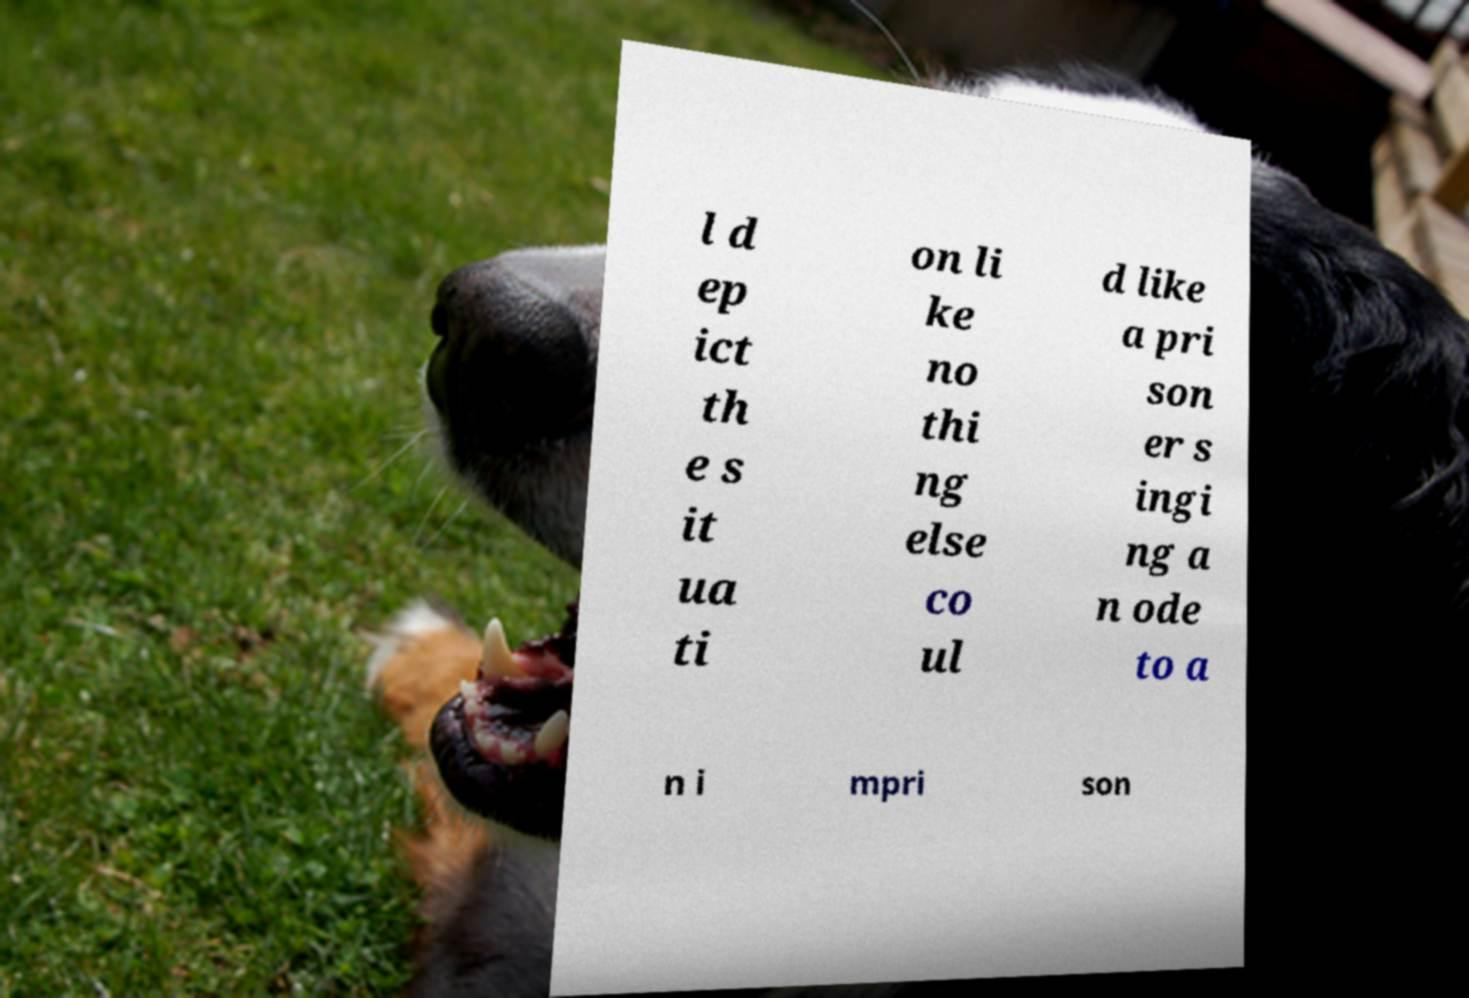Can you accurately transcribe the text from the provided image for me? l d ep ict th e s it ua ti on li ke no thi ng else co ul d like a pri son er s ingi ng a n ode to a n i mpri son 